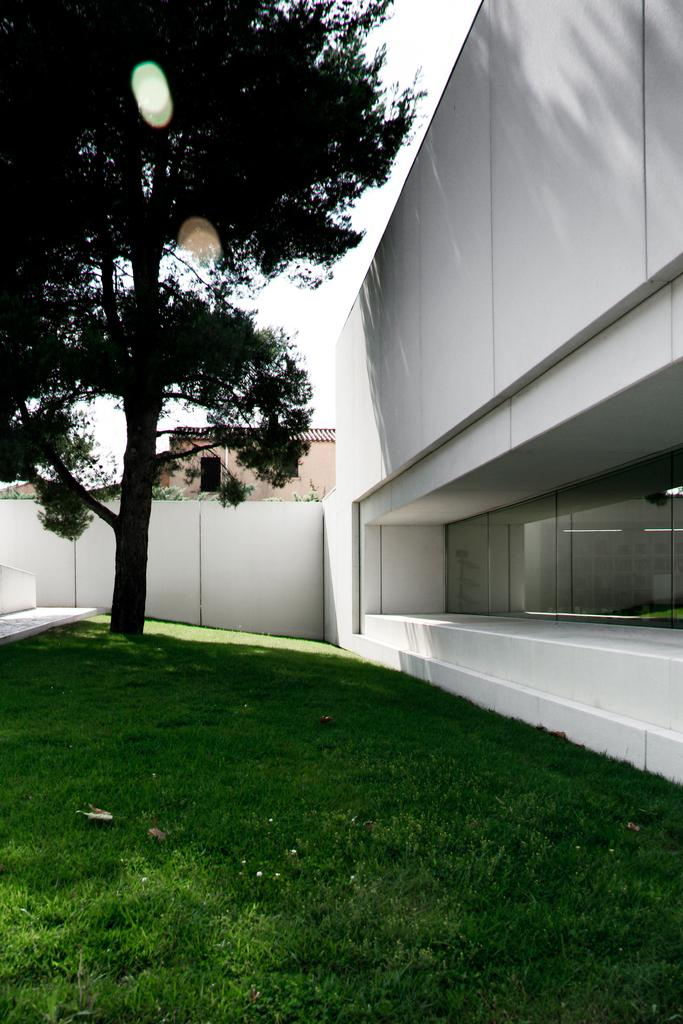What type of vegetation is present in the image? There is grass in the image. What structure is located on the left side of the image? There is a white building on the left side of the image. What other natural element can be seen in the image? There is a tree in the image. What architectural feature is present in the image? There is a wall in the image. What other building is visible in the image? There is a building at the back of the image. What is visible at the top of the image? The sky is visible at the top of the image. How many toes are visible on the building in the image? There are no toes visible in the image, as buildings do not have toes. 